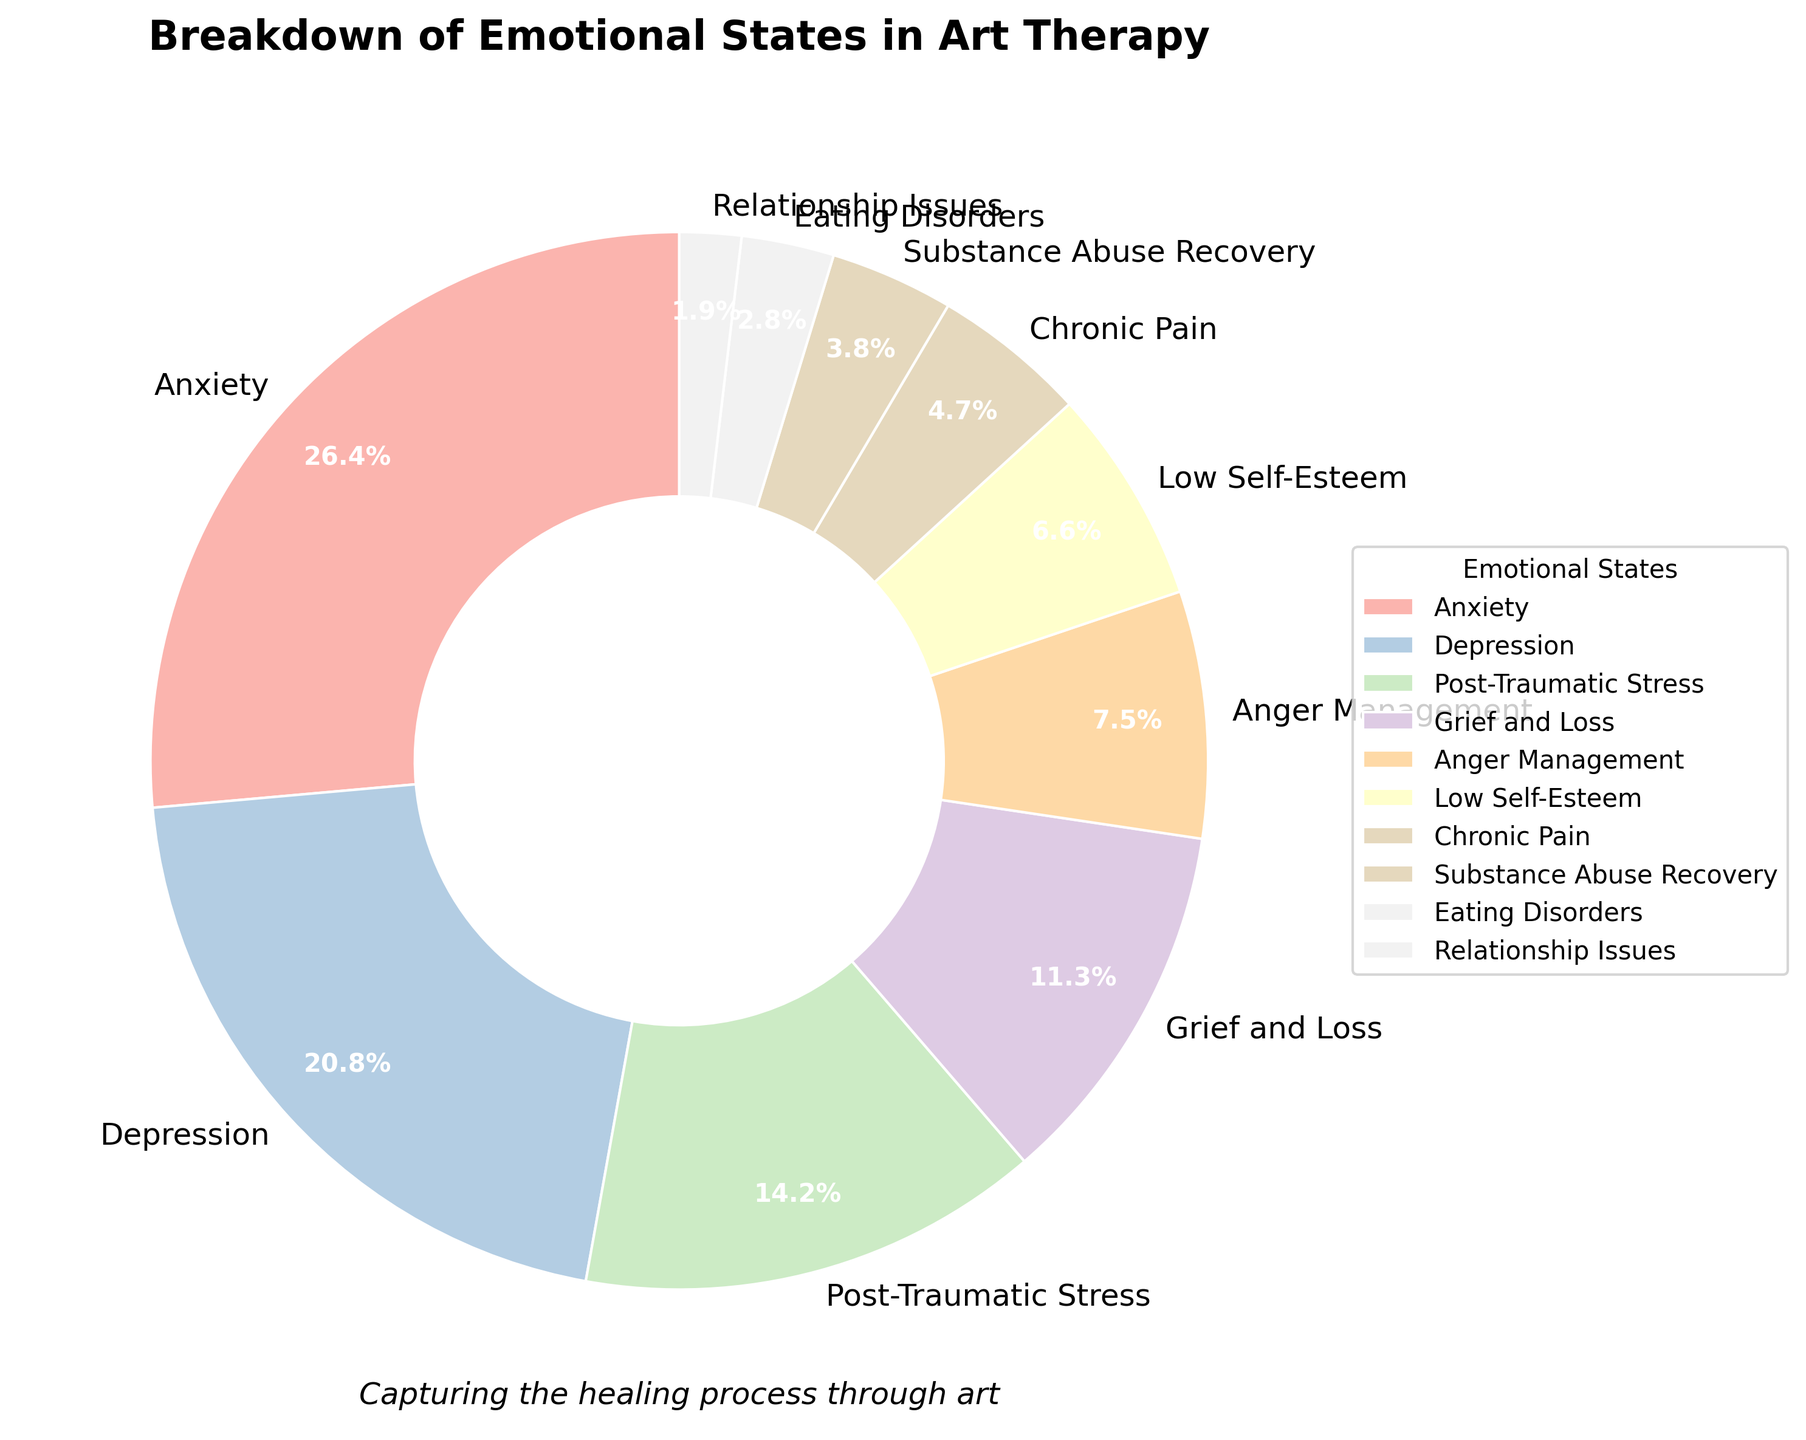What's the most addressed emotional state in art therapy according to the chart? The chart shows the largest segment representing the emotional state. By inspecting the sizes and reading the labels, the largest segment is for Anxiety at 28%.
Answer: Anxiety Which two emotional states combined account for more than half of the sessions? To answer this, we add the percentages of the emotional states and check which two combined sum to greater than 50%. Anxiety (28%) + Depression (22%) = 50%, which is exactly half. Since the problem asks for more than half, adding another state is needed. Anxiety (28%) + Depression (22%) + Post-Traumatic Stress (15%) = 65%, which is greater than 50%.
Answer: Anxiety and Depression Which emotional states have a similar percentage and what are their values? The chart indicates that some percentages are close in value. By comparing the segments and their labels, Grief and Loss and Anger Management have similar percentages, Grief and Loss at 12% and Anger Management at 8%. They are within a close range to each other.
Answer: Grief and Loss (12%) and Anger Management (8%) How many emotional states have a percentage less than 10%? By checking each segment on the chart and reading their labels, count the emotional states with percentages less than 10%. These are Anger Management (8%), Low Self-Esteem (7%), Chronic Pain (5%), Substance Abuse Recovery (4%), Eating Disorders (3%), and Relationship Issues (2%). This adds up to six emotional states.
Answer: Six If you combine Low Self-Esteem, Chronic Pain, and Substance Abuse Recovery, what percentage do you get? Add the percentages of Low Self-Esteem (7%), Chronic Pain (5%), and Substance Abuse Recovery (4%). 7% + 5% + 4% = 16%.
Answer: 16% Which segment appears the smallest and what percentage does it represent? By visually inspecting the sizes of the segments and referring to their labels, Relationship Issues is the smallest segment and represents 2%.
Answer: Relationship Issues (2%) Is the percentage of Depression larger than Post-Traumatic Stress? Compare the percentages of Depression and Post-Traumatic Stress. Depression is 22%, and Post-Traumatic Stress is 15%. Hence, Depression is larger than Post-Traumatic Stress.
Answer: Yes What is the combined percentage of Grief and Loss, and Eating Disorders? Add the percentages of Grief and Loss (12%) and Eating Disorders (3%). 12% + 3% = 15%.
Answer: 15% Which segments together exceed the percentage of Anxiety? Check the combinations of segments that together exceed the percentage for Anxiety (28%). One such combination is Depression (22%) and Post-Traumatic Stress (15%), which sums up to 37%, exceeding Anxiety's 28%.
Answer: Depression and Post-Traumatic Stress 